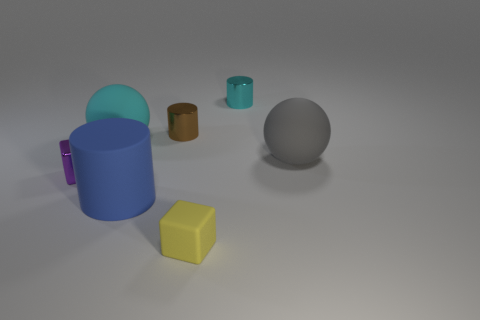Do the sphere that is behind the gray sphere and the big gray sphere have the same material?
Your answer should be very brief. Yes. How many things are left of the yellow rubber thing and in front of the small purple thing?
Your response must be concise. 1. How big is the cylinder in front of the purple thing that is behind the large blue rubber cylinder?
Your answer should be very brief. Large. Is there anything else that has the same material as the tiny cyan cylinder?
Keep it short and to the point. Yes. Is the number of small purple shiny objects greater than the number of large purple metallic balls?
Your response must be concise. Yes. There is a small block to the right of the metal block; does it have the same color as the large rubber sphere that is behind the gray thing?
Offer a terse response. No. Are there any tiny brown objects that are on the left side of the rubber sphere that is behind the gray thing?
Give a very brief answer. No. Are there fewer matte cylinders to the left of the big blue cylinder than objects that are behind the gray thing?
Make the answer very short. Yes. Is the ball that is on the left side of the large cylinder made of the same material as the cylinder that is in front of the gray ball?
Give a very brief answer. Yes. How many big things are cyan rubber things or yellow rubber cubes?
Give a very brief answer. 1. 